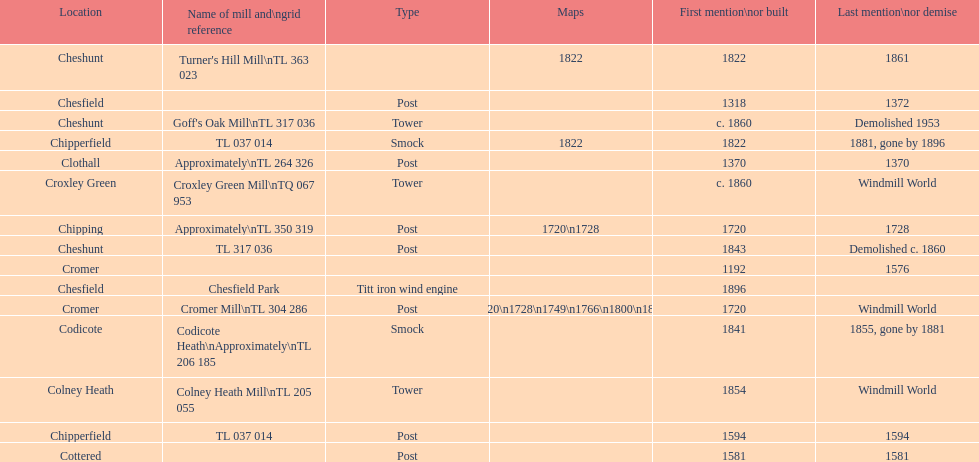How man "c" windmills have there been? 15. 